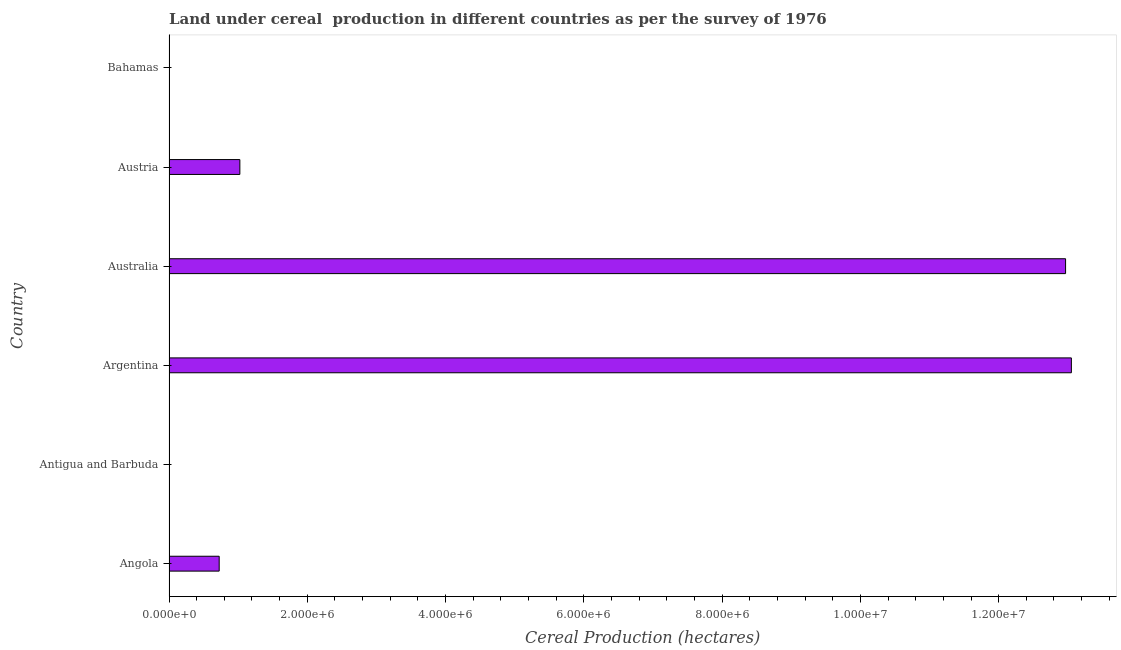What is the title of the graph?
Ensure brevity in your answer.  Land under cereal  production in different countries as per the survey of 1976. What is the label or title of the X-axis?
Offer a very short reply. Cereal Production (hectares). What is the label or title of the Y-axis?
Keep it short and to the point. Country. What is the land under cereal production in Antigua and Barbuda?
Your response must be concise. 28. Across all countries, what is the maximum land under cereal production?
Your answer should be compact. 1.31e+07. Across all countries, what is the minimum land under cereal production?
Offer a terse response. 28. In which country was the land under cereal production maximum?
Keep it short and to the point. Argentina. In which country was the land under cereal production minimum?
Your answer should be very brief. Antigua and Barbuda. What is the sum of the land under cereal production?
Give a very brief answer. 2.78e+07. What is the difference between the land under cereal production in Angola and Antigua and Barbuda?
Offer a very short reply. 7.26e+05. What is the average land under cereal production per country?
Ensure brevity in your answer.  4.63e+06. What is the median land under cereal production?
Make the answer very short. 8.75e+05. In how many countries, is the land under cereal production greater than 3600000 hectares?
Provide a succinct answer. 2. What is the ratio of the land under cereal production in Antigua and Barbuda to that in Austria?
Provide a succinct answer. 0. What is the difference between the highest and the second highest land under cereal production?
Keep it short and to the point. 8.38e+04. What is the difference between the highest and the lowest land under cereal production?
Offer a very short reply. 1.31e+07. In how many countries, is the land under cereal production greater than the average land under cereal production taken over all countries?
Offer a terse response. 2. How many bars are there?
Make the answer very short. 6. Are all the bars in the graph horizontal?
Provide a succinct answer. Yes. What is the Cereal Production (hectares) in Angola?
Keep it short and to the point. 7.26e+05. What is the Cereal Production (hectares) of Argentina?
Your answer should be very brief. 1.31e+07. What is the Cereal Production (hectares) of Australia?
Give a very brief answer. 1.30e+07. What is the Cereal Production (hectares) of Austria?
Give a very brief answer. 1.02e+06. What is the Cereal Production (hectares) in Bahamas?
Your answer should be very brief. 612. What is the difference between the Cereal Production (hectares) in Angola and Antigua and Barbuda?
Keep it short and to the point. 7.26e+05. What is the difference between the Cereal Production (hectares) in Angola and Argentina?
Make the answer very short. -1.23e+07. What is the difference between the Cereal Production (hectares) in Angola and Australia?
Keep it short and to the point. -1.22e+07. What is the difference between the Cereal Production (hectares) in Angola and Austria?
Keep it short and to the point. -2.99e+05. What is the difference between the Cereal Production (hectares) in Angola and Bahamas?
Your response must be concise. 7.25e+05. What is the difference between the Cereal Production (hectares) in Antigua and Barbuda and Argentina?
Make the answer very short. -1.31e+07. What is the difference between the Cereal Production (hectares) in Antigua and Barbuda and Australia?
Provide a short and direct response. -1.30e+07. What is the difference between the Cereal Production (hectares) in Antigua and Barbuda and Austria?
Ensure brevity in your answer.  -1.02e+06. What is the difference between the Cereal Production (hectares) in Antigua and Barbuda and Bahamas?
Offer a very short reply. -584. What is the difference between the Cereal Production (hectares) in Argentina and Australia?
Make the answer very short. 8.38e+04. What is the difference between the Cereal Production (hectares) in Argentina and Austria?
Keep it short and to the point. 1.20e+07. What is the difference between the Cereal Production (hectares) in Argentina and Bahamas?
Offer a very short reply. 1.31e+07. What is the difference between the Cereal Production (hectares) in Australia and Austria?
Ensure brevity in your answer.  1.19e+07. What is the difference between the Cereal Production (hectares) in Australia and Bahamas?
Your answer should be very brief. 1.30e+07. What is the difference between the Cereal Production (hectares) in Austria and Bahamas?
Your response must be concise. 1.02e+06. What is the ratio of the Cereal Production (hectares) in Angola to that in Antigua and Barbuda?
Give a very brief answer. 2.59e+04. What is the ratio of the Cereal Production (hectares) in Angola to that in Argentina?
Give a very brief answer. 0.06. What is the ratio of the Cereal Production (hectares) in Angola to that in Australia?
Your answer should be very brief. 0.06. What is the ratio of the Cereal Production (hectares) in Angola to that in Austria?
Provide a short and direct response. 0.71. What is the ratio of the Cereal Production (hectares) in Angola to that in Bahamas?
Ensure brevity in your answer.  1186.28. What is the ratio of the Cereal Production (hectares) in Antigua and Barbuda to that in Argentina?
Provide a short and direct response. 0. What is the ratio of the Cereal Production (hectares) in Antigua and Barbuda to that in Austria?
Keep it short and to the point. 0. What is the ratio of the Cereal Production (hectares) in Antigua and Barbuda to that in Bahamas?
Offer a very short reply. 0.05. What is the ratio of the Cereal Production (hectares) in Argentina to that in Australia?
Offer a very short reply. 1.01. What is the ratio of the Cereal Production (hectares) in Argentina to that in Austria?
Ensure brevity in your answer.  12.73. What is the ratio of the Cereal Production (hectares) in Argentina to that in Bahamas?
Offer a terse response. 2.13e+04. What is the ratio of the Cereal Production (hectares) in Australia to that in Austria?
Your answer should be compact. 12.65. What is the ratio of the Cereal Production (hectares) in Australia to that in Bahamas?
Your answer should be very brief. 2.12e+04. What is the ratio of the Cereal Production (hectares) in Austria to that in Bahamas?
Offer a terse response. 1674.62. 